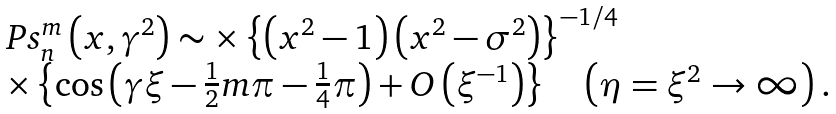<formula> <loc_0><loc_0><loc_500><loc_500>\begin{array} [ c ] { l } P s _ { n } ^ { m } \left ( { x , \gamma ^ { 2 } } \right ) \sim \times \left \{ { \left ( { x ^ { 2 } - 1 } \right ) \left ( { x ^ { 2 } - \sigma ^ { 2 } } \right ) } \right \} ^ { - 1 / 4 } \\ \times \left \{ { \cos \left ( { \gamma \xi - \frac { 1 } { 2 } m \pi - \frac { 1 } { 4 } \pi } \right ) + { O } \left ( \xi ^ { - 1 } \right ) } \right \} \quad \left ( { \eta = \xi ^ { 2 } \rightarrow \infty } \right ) . \end{array}</formula> 